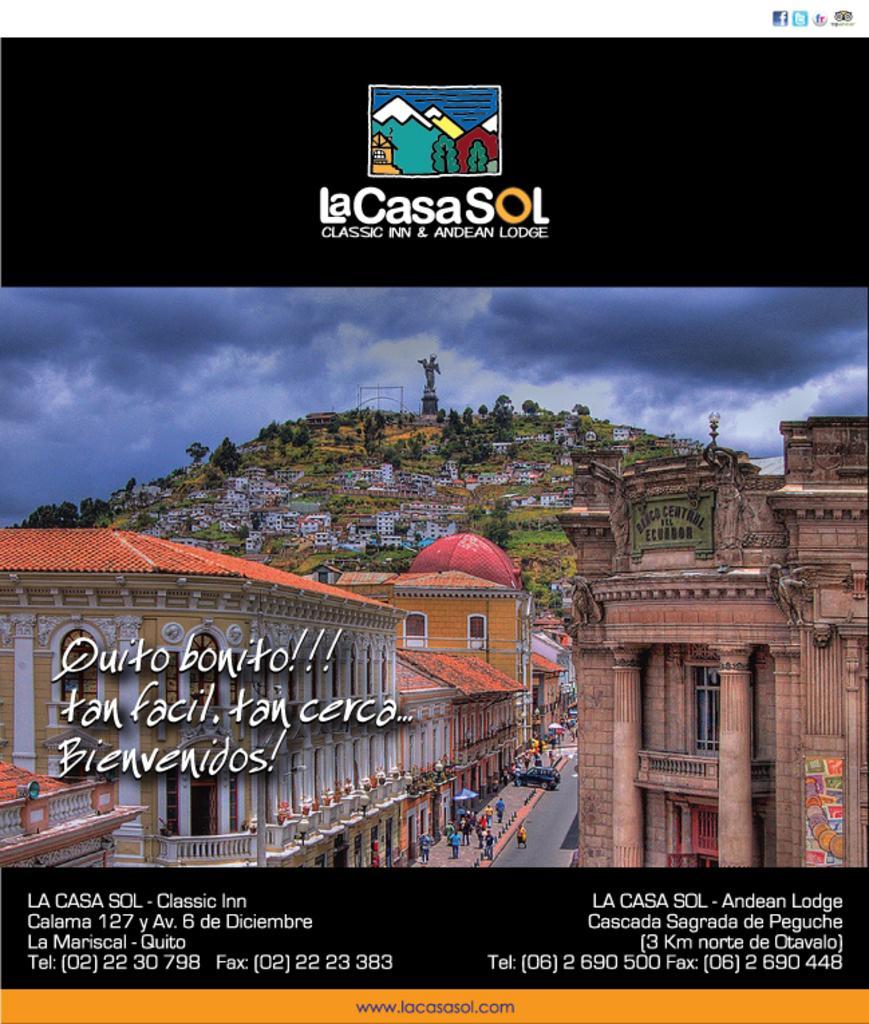Can you describe this image briefly? In this image there is a city, in that city there is a road on that road people are walking, in the background there is a mountain on that there are houses people are walking 